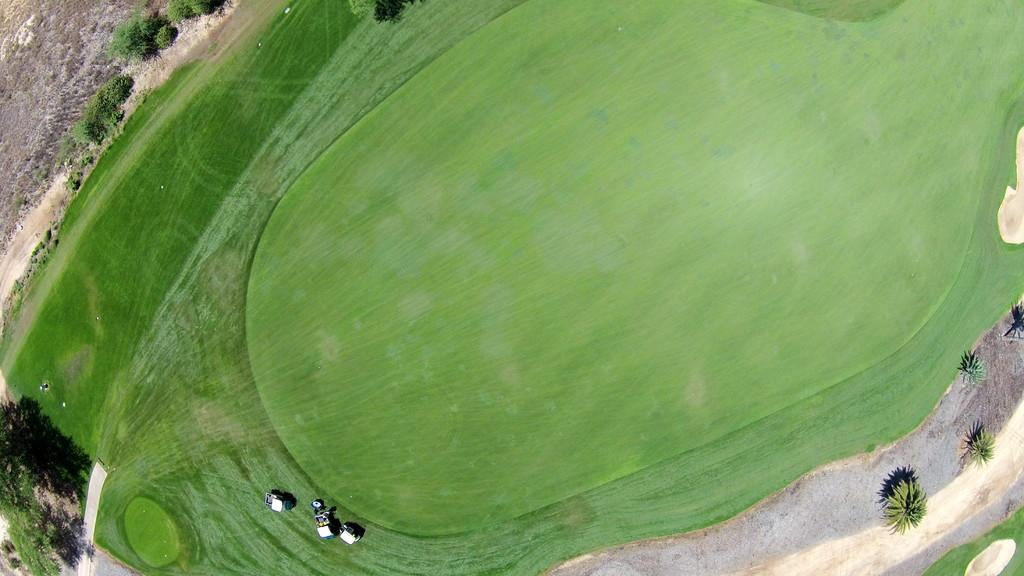What can be seen at the base of the image? There are things on the bottom left of the image. What type of natural environment is visible in the image? There are trees in the image. What is the surface on which the objects are placed in the image? The ground is visible in the image. How many balls are present in the image? There is no ball present in the image. Is there a tub visible in the image? There is no tub present in the image. 